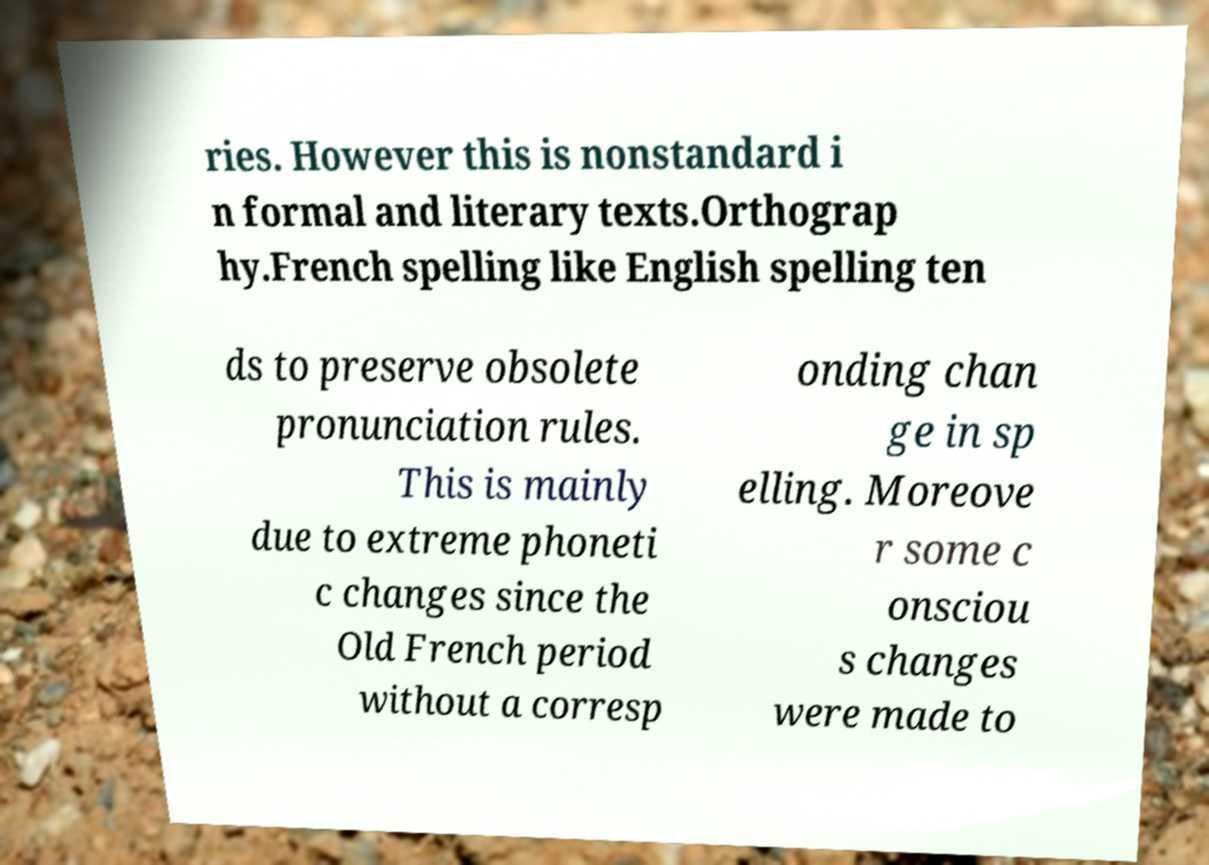Could you extract and type out the text from this image? ries. However this is nonstandard i n formal and literary texts.Orthograp hy.French spelling like English spelling ten ds to preserve obsolete pronunciation rules. This is mainly due to extreme phoneti c changes since the Old French period without a corresp onding chan ge in sp elling. Moreove r some c onsciou s changes were made to 